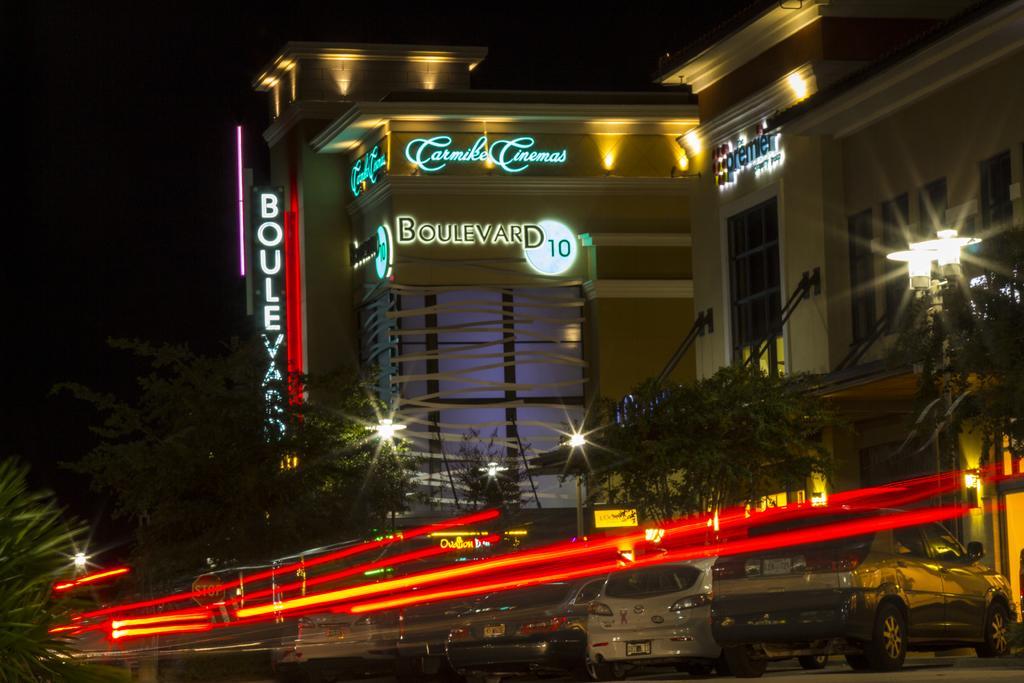Can you describe this image briefly? In this image we can see buildings with some text on them. There are trees, lights. At the bottom of the image there are cars. This image is taken during the night time. 